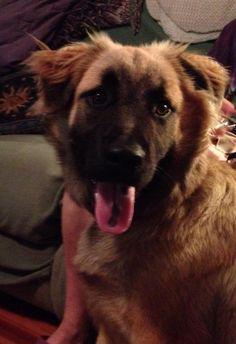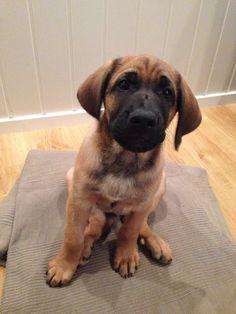The first image is the image on the left, the second image is the image on the right. Assess this claim about the two images: "In one image a dog is outdoors with its tongue showing.". Correct or not? Answer yes or no. No. 